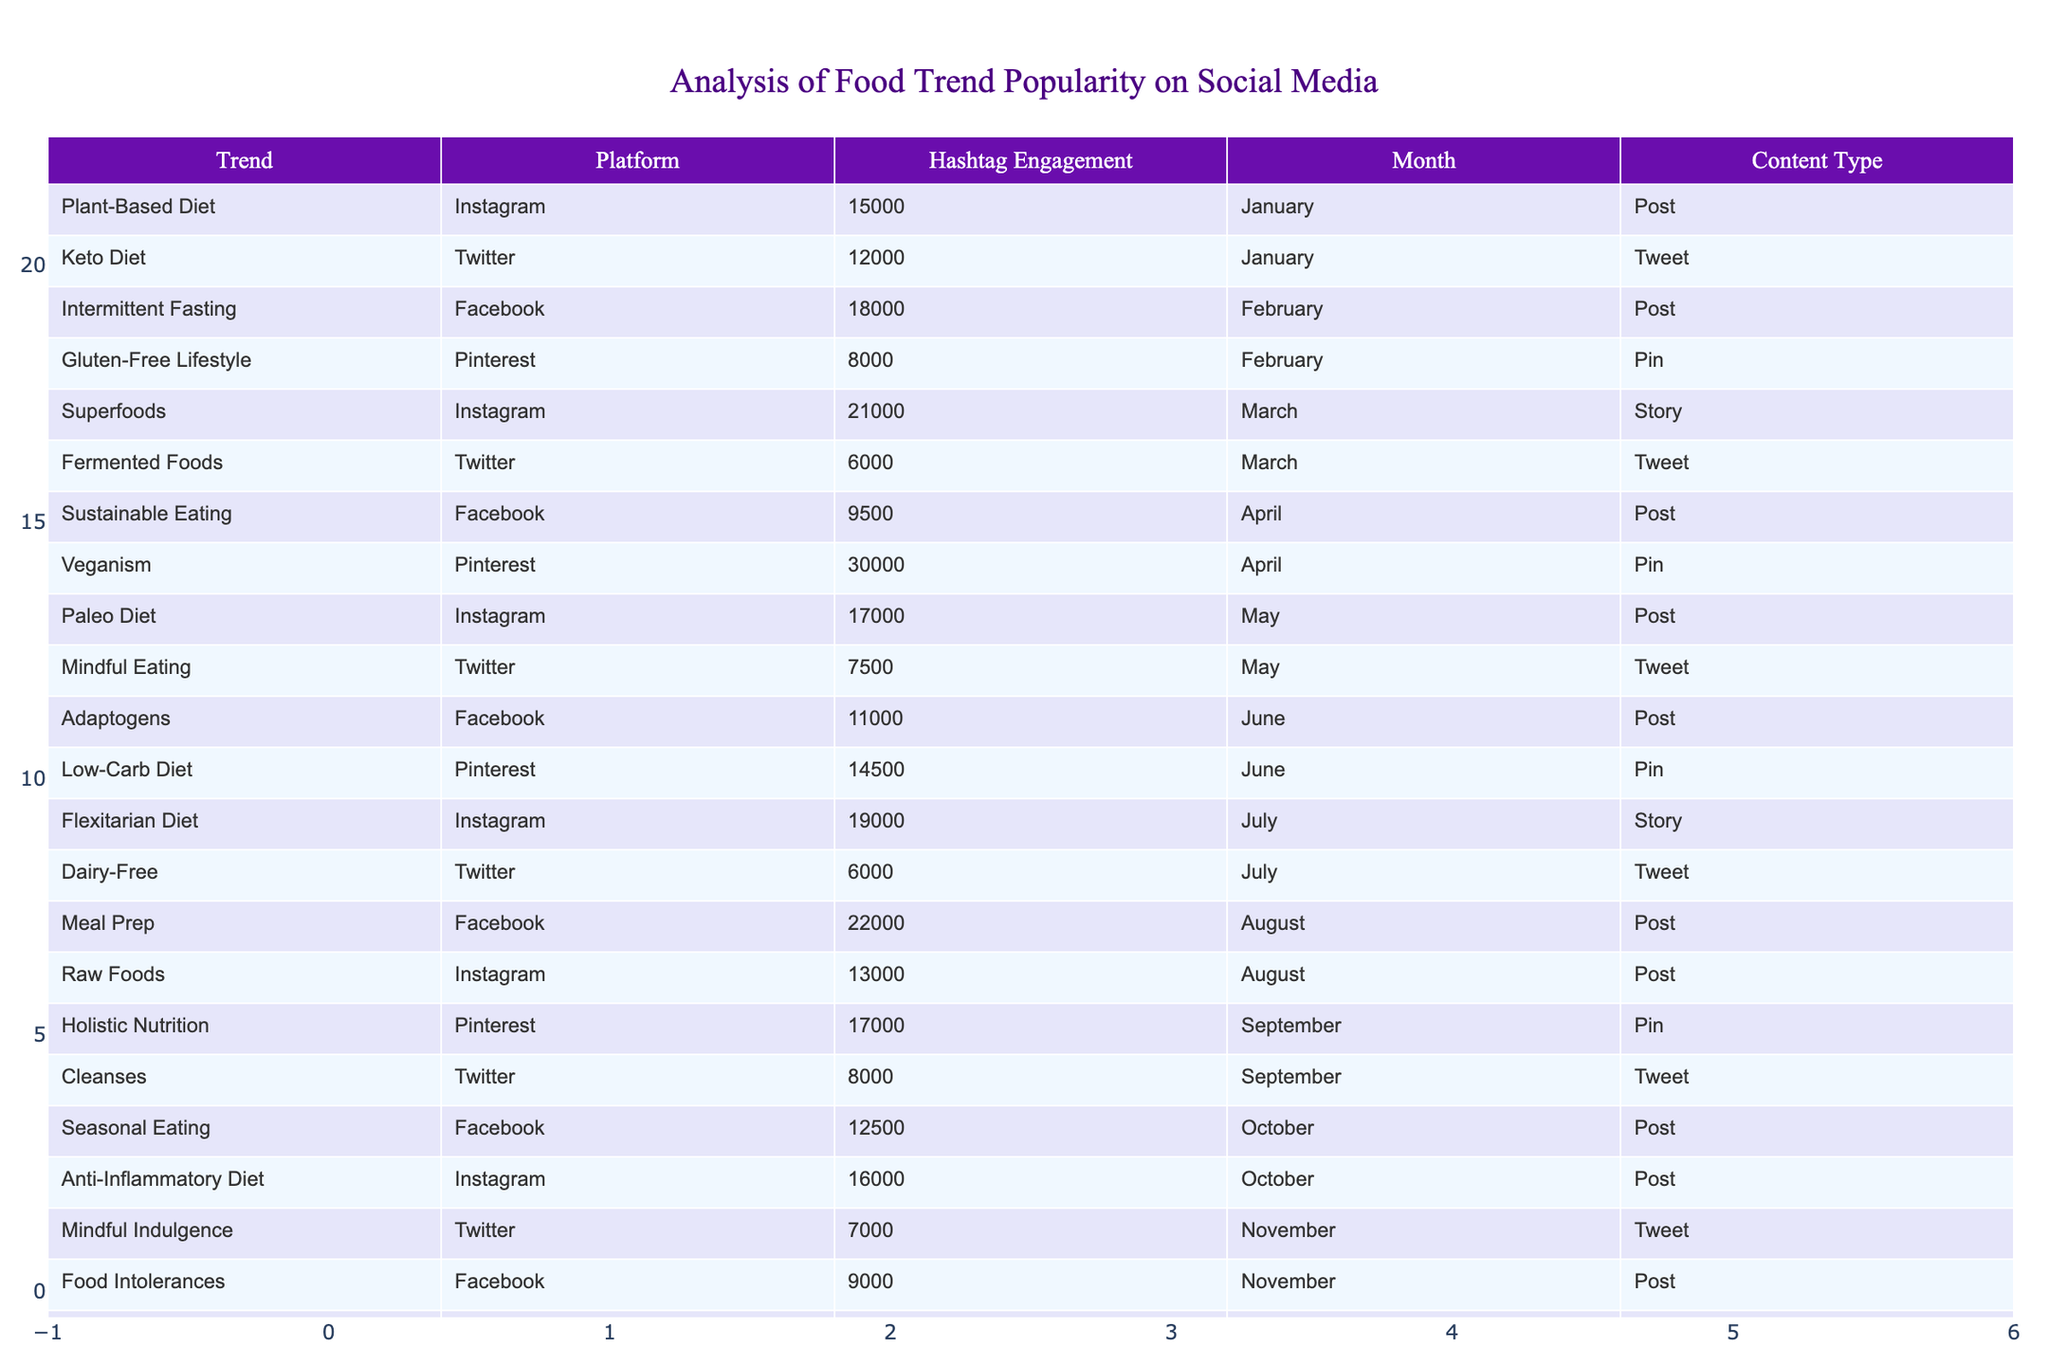What was the highest engagement recorded on social media for a food trend? The highest engagement was for "Veganism" on Pinterest in April, with 30,000 engagements.
Answer: 30,000 Which month saw the popularization of the "Superfoods" trend? "Superfoods" was popularized in March as per the records on Instagram.
Answer: March How many food trends had engagement over 20,000 in total? The food trends with engagements over 20,000 were "Superfoods", "Veganism", and "Meal Prep", yielding a total of three such trends.
Answer: 3 Did "Intermittent Fasting" have more engagement than "Gluten-Free Lifestyle" on social media? Yes, "Intermittent Fasting" had 18,000 engagements while "Gluten-Free Lifestyle" had only 8,000 engagements, indicating a higher popularity for the former.
Answer: Yes What was the average engagement for food trends on Instagram? To find the average engagement, we sum the engagements from Instagram: (15,000 + 21,000 + 17,000 + 19,000 + 13,000 + 14,000) which equals 99,000, then we divide by the 6 months giving us 99,000/6 = 16,500.
Answer: 16,500 In which platform did the "Flexitarian Diet" trend perform the best? "Flexitarian Diet" performed the best on Instagram with 19,000 engagements, as per the table.
Answer: Instagram What engagement did "Food Intolerances" receive in November? "Food Intolerances" received 9,000 engagements in November.
Answer: 9,000 How many different platforms are represented in the table? The platforms represented in the table are Instagram, Twitter, Facebook, and Pinterest, totaling four distinct platforms.
Answer: 4 Which content type saw the highest engagement in the month of August? The content type "Post" had the highest engagement with "Meal Prep" attracting 22,000 engagements in August.
Answer: Post 